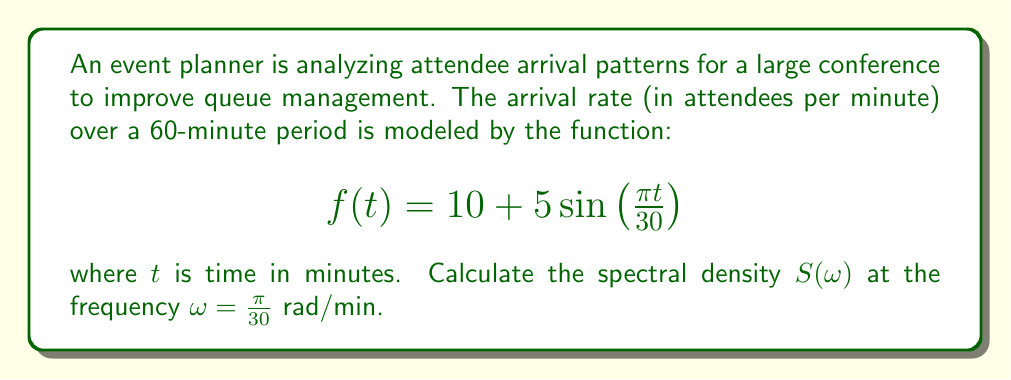Help me with this question. To calculate the spectral density, we need to follow these steps:

1) First, we need to find the Fourier transform of $f(t)$. The Fourier transform is given by:

   $$F(\omega) = \int_{-\infty}^{\infty} f(t) e^{-i\omega t} dt$$

2) For our function $f(t) = 10 + 5\sin\left(\frac{\pi t}{30}\right)$, we can split this into two parts:
   
   a) The constant part: $10$
   b) The sinusoidal part: $5\sin\left(\frac{\pi t}{30}\right)$

3) The Fourier transform of a constant is a delta function:
   
   $$\mathcal{F}\{10\} = 20\pi\delta(\omega)$$

4) For the sinusoidal part, we can use the Fourier transform property of sine:
   
   $$\mathcal{F}\{5\sin(at)\} = \frac{5\pi i}{2}[\delta(\omega-a) - \delta(\omega+a)]$$

   Where in our case, $a = \frac{\pi}{30}$

5) Combining these, we get:

   $$F(\omega) = 20\pi\delta(\omega) + \frac{5\pi i}{2}[\delta(\omega-\frac{\pi}{30}) - \delta(\omega+\frac{\pi}{30})]$$

6) The spectral density is defined as:

   $$S(\omega) = \lim_{T\to\infty} \frac{1}{T} |F(\omega)|^2$$

7) At $\omega = \frac{\pi}{30}$, only the second delta function in our Fourier transform is non-zero. Therefore:

   $$S(\frac{\pi}{30}) = \lim_{T\to\infty} \frac{1}{T} |\frac{5\pi i}{2}|^2 = \lim_{T\to\infty} \frac{25\pi^2}{4T}$$

8) The limit as $T$ approaches infinity of any constant divided by $T$ is zero. However, for finite observation times, we can approximate this as:

   $$S(\frac{\pi}{30}) \approx \frac{25\pi^2}{4T}$$

   Where $T$ is the observation time, which in this case is 60 minutes.

9) Substituting $T = 60$:

   $$S(\frac{\pi}{30}) \approx \frac{25\pi^2}{4(60)} = \frac{25\pi^2}{240} \approx 0.8181$$
Answer: The spectral density at $\omega = \frac{\pi}{30}$ rad/min is approximately $\frac{25\pi^2}{240} \approx 0.8181$ (attendees/min)^2 * min. 